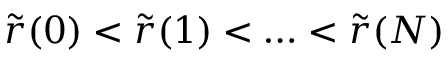Convert formula to latex. <formula><loc_0><loc_0><loc_500><loc_500>\tilde { r } ( 0 ) < \tilde { r } ( 1 ) < \dots < \tilde { r } ( N )</formula> 